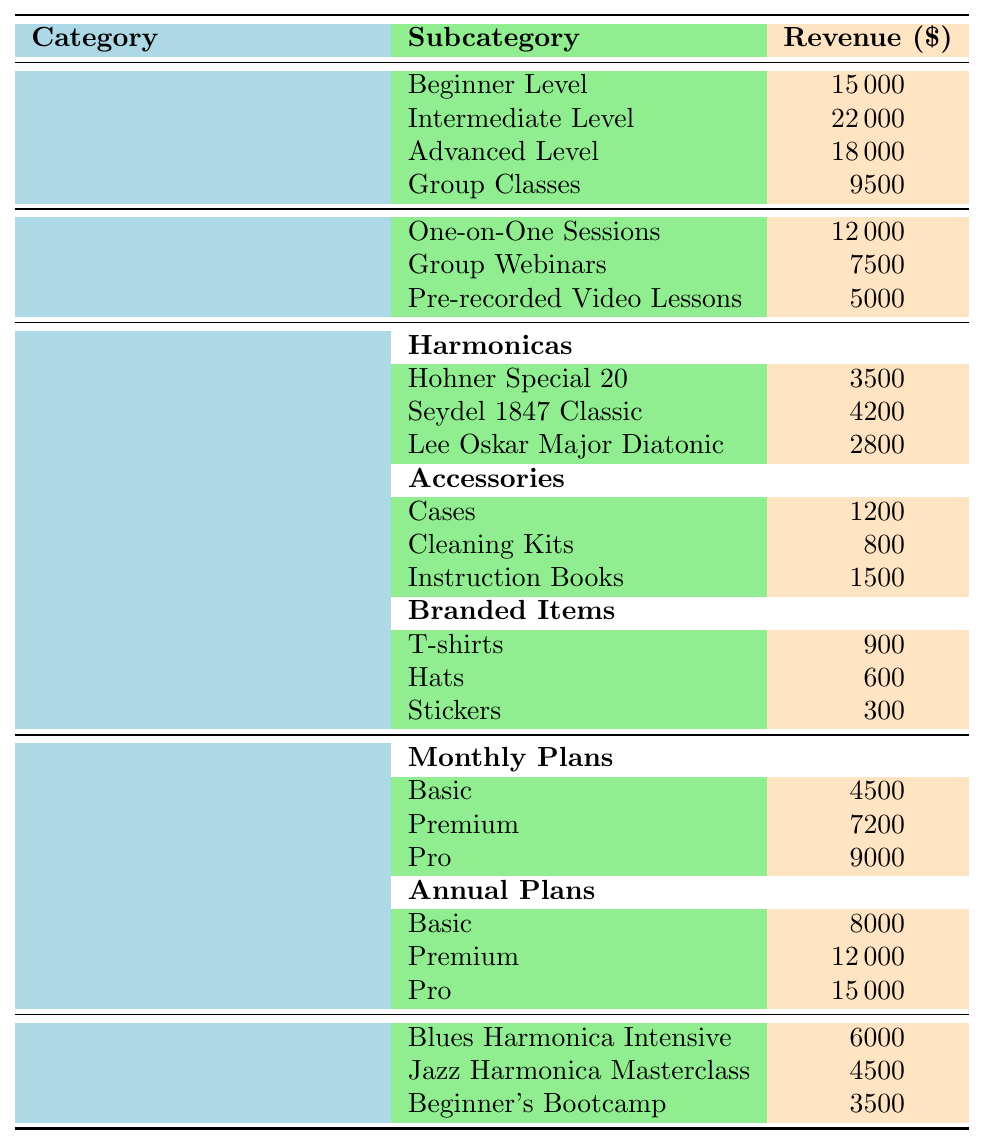What is the total revenue from In-Person Lessons? To find the total revenue from In-Person Lessons, we need to sum the revenues of each level: 15000 (Beginner) + 22000 (Intermediate) + 18000 (Advanced) + 9500 (Group Classes) = 65000.
Answer: 65000 Which merchandise category generated the highest revenue? We need to compare the total revenues from Harmonicas, Accessories, and Branded Items. The totals are: Harmonicas = 3500 + 4200 + 2800 = 10500, Accessories = 1200 + 800 + 1500 = 3500, Branded Items = 900 + 600 + 300 = 1800. The highest is Harmonicas with 10500.
Answer: Harmonicas What is the revenue from the most expensive online course subscription plan? The most expensive plan is the Pro for Annual Plans at 15000, as visible in the table.
Answer: 15000 How much revenue was generated from the different types of Online Lessons combined? To find the total from Online Lessons, we sum One-on-One Sessions (12000) + Group Webinars (7500) + Pre-recorded Video Lessons (5000) = 29500.
Answer: 29500 Is the revenue from the Beginner Level of In-Person Lessons greater than any merchandise category? The revenue from the Beginner Level is 15000. Merchandise categories have revenues of Harmonicas (10500), Accessories (3500), and Branded Items (1800). Since 15000 is greater than 10500, the answer is yes.
Answer: Yes What is the average revenue of the three types of Online Course Subscriptions? We first calculate the total revenue from all subscriptions: 4500 (Basic Monthly) + 7200 (Premium Monthly) + 9000 (Pro Monthly) + 8000 (Basic Annual) + 12000 (Premium Annual) + 15000 (Pro Annual) = 48000. There are 6 plans, so the average is 48000 / 6 = 8000.
Answer: 8000 What is the total revenue from workshops? To find the total revenue, we add all workshop revenues: 6000 (Blues Harmonica Intensive) + 4500 (Jazz Harmonica Masterclass) + 3500 (Beginner's Bootcamp) = 14000.
Answer: 14000 Which had more revenue: Group Classes from In-Person Lessons or Group Webinars from Online Lessons? The revenue from Group Classes is 9500, while the revenue from Group Webinars is 7500. Since 9500 is greater than 7500, Group Classes had more revenue.
Answer: Group Classes What is the combined revenue from merchandise sales? We need to sum the revenues from each merchandise category. Harmonicas = 10500, Accessories = 3500, Branded Items = 1800. Thus, total merchandise revenue = 10500 + 3500 + 1800 = 15800.
Answer: 15800 If we compare all types of lessons, which type yielded the highest revenue? In-Person Lessons totaled 65000 while Online Lessons totaled 29500. In-Person Lessons are higher.
Answer: In-Person Lessons 